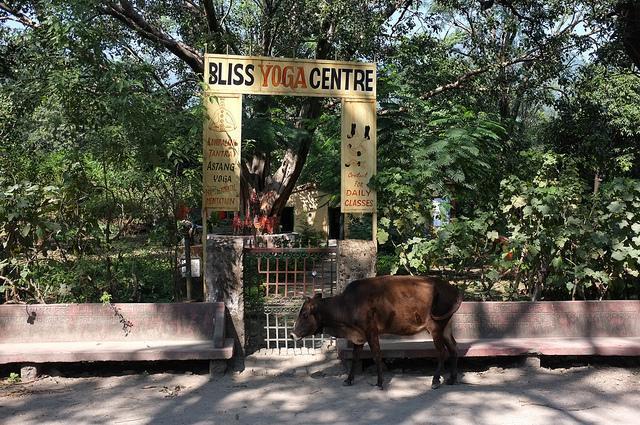How many benches can you see?
Give a very brief answer. 2. 